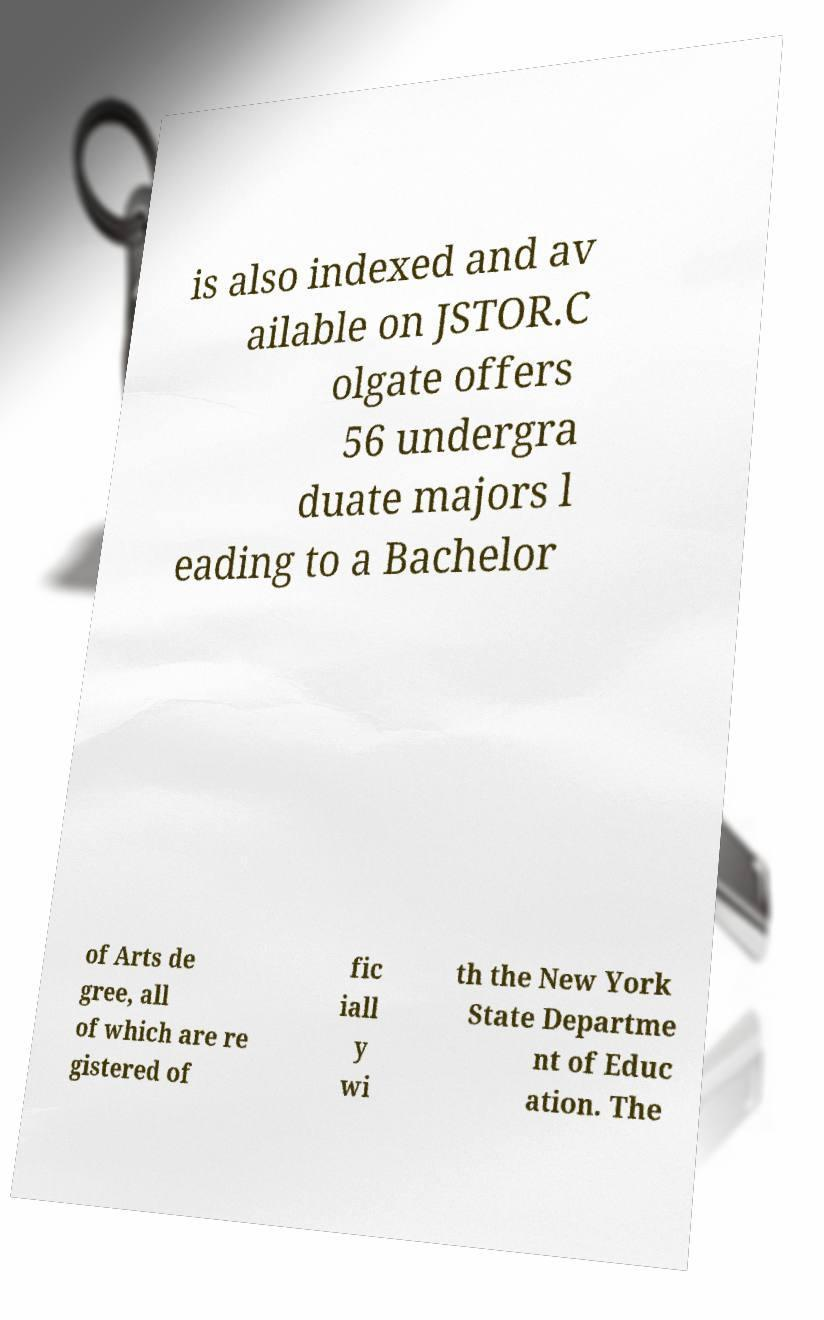Please read and relay the text visible in this image. What does it say? is also indexed and av ailable on JSTOR.C olgate offers 56 undergra duate majors l eading to a Bachelor of Arts de gree, all of which are re gistered of fic iall y wi th the New York State Departme nt of Educ ation. The 